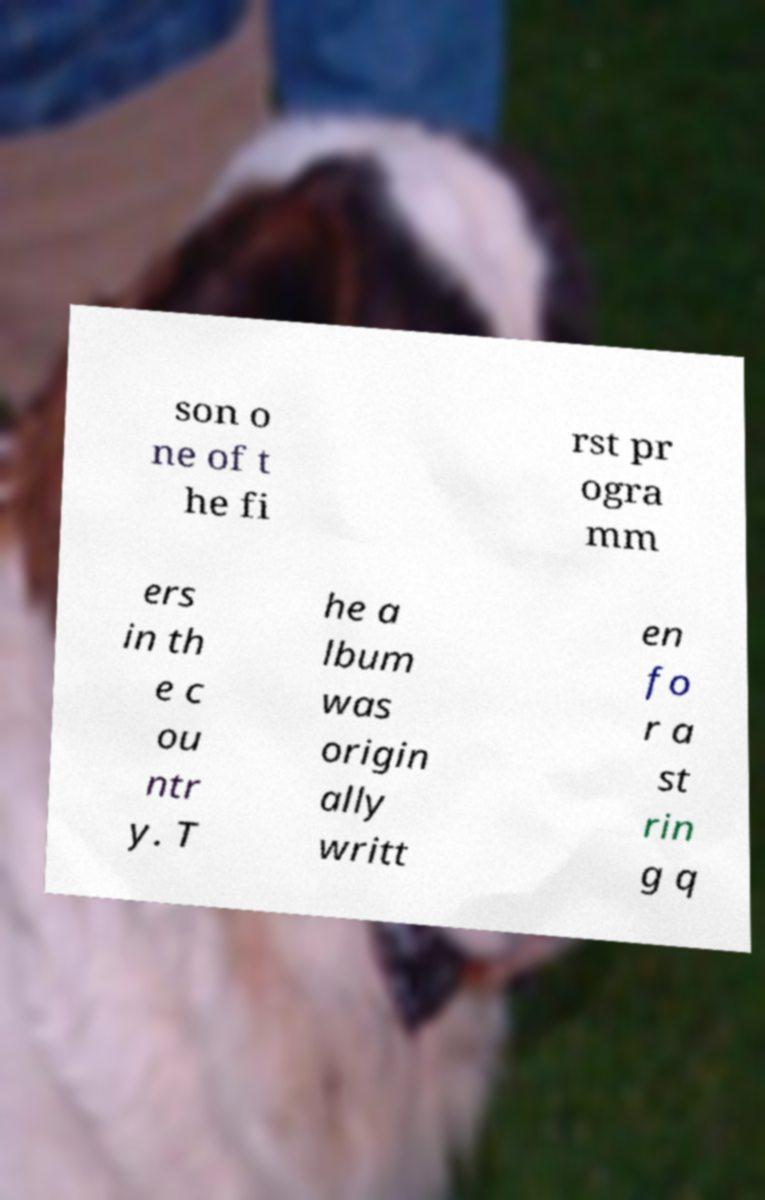I need the written content from this picture converted into text. Can you do that? son o ne of t he fi rst pr ogra mm ers in th e c ou ntr y. T he a lbum was origin ally writt en fo r a st rin g q 